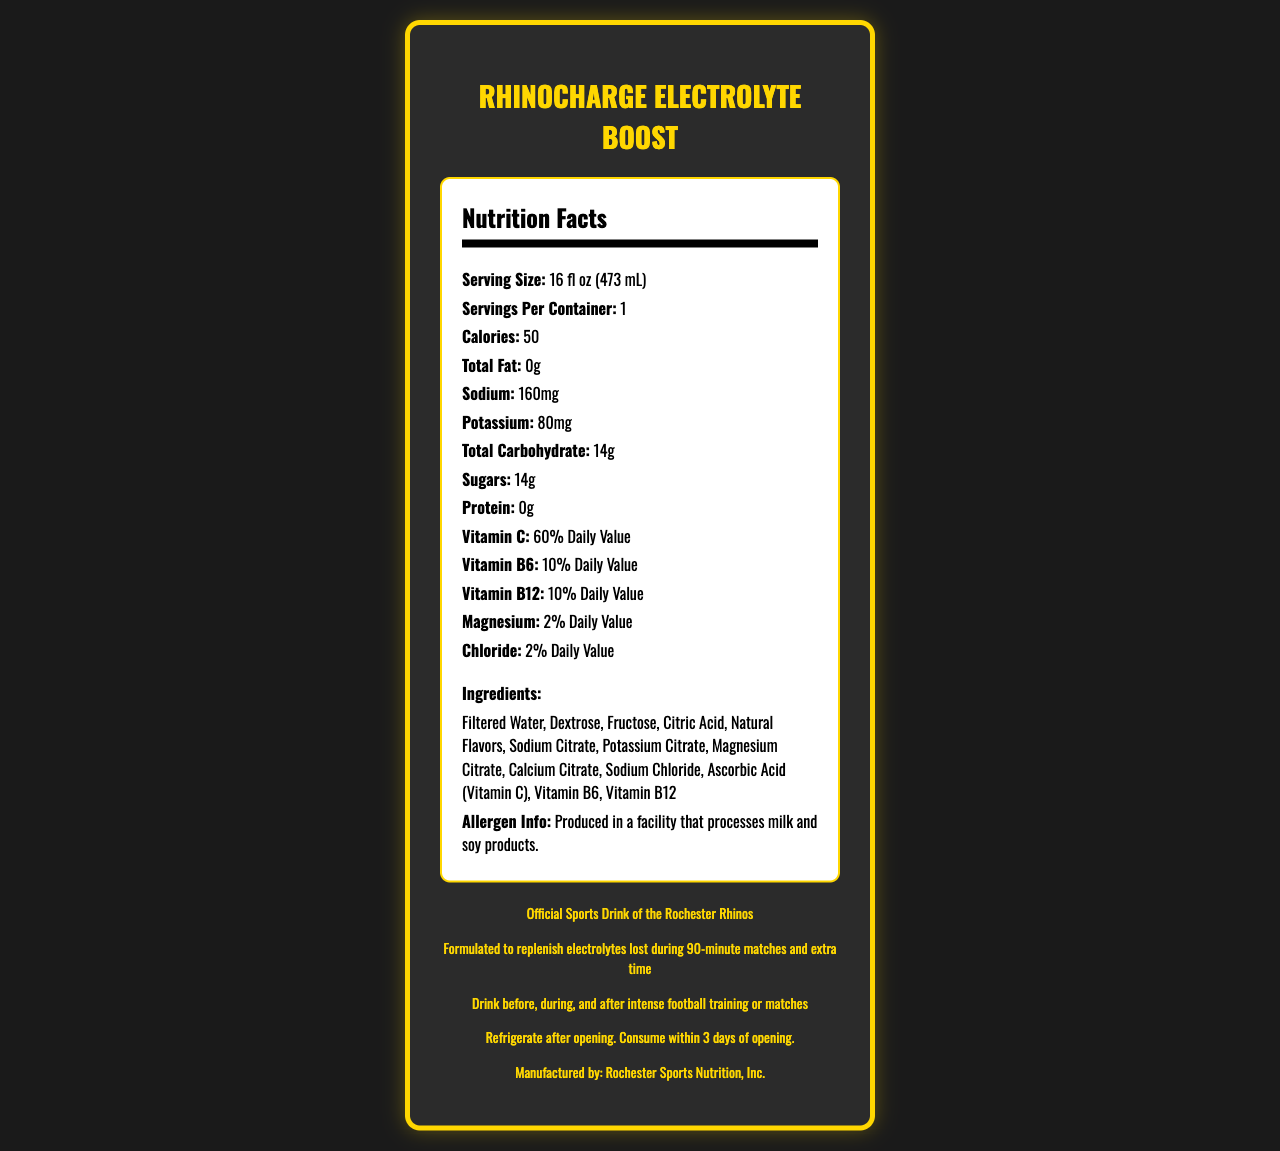what is the serving size of RhinoCharge Electrolyte Boost? The serving size is clearly listed as "16 fl oz (473 mL)" under the Nutrition Facts.
Answer: 16 fl oz (473 mL) how many calories are in a serving? The number of calories is listed as 50 in the Nutrition Facts section.
Answer: 50 what are the main electrolytes in this sports drink? The primary electrolytes mentioned in the ingredients are Sodium, Potassium, and Magnesium Citrate, and Sodium Chloride.
Answer: Sodium, Potassium, Magnesium, Chloride how much sugar is in a serving? The amount of sugar per serving is listed as 14g.
Answer: 14g what percentage of the daily value of Vitamin C does this drink provide? The document states that the drink provides 60% of the daily value for Vitamin C.
Answer: 60% how many servings are in one container of this drink? It is mentioned under the Nutrition Facts that there are 1 serving per container.
Answer: 1 what are the first three ingredients listed? A. Filtered Water, Dextrose, Fructose B. Dextrose, Fructose, Citric Acid C. Fructose, Citric Acid, Natural Flavors The ingredients are listed in order, and the first three are Filtered Water, Dextrose, and Fructose.
Answer: A. Filtered Water, Dextrose, Fructose which nutrient has the highest percentage of daily value? 1. Vitamin C 2. Vitamin B6 3. Magnesium 4. Potassium Among the listed nutrients, Vitamin C has the highest daily value percentage at 60%.
Answer: 1. Vitamin C does the sports drink contain any fat? The Nutrition Facts section indicates that the total fat content is 0g.
Answer: No is the RhinoCharge Electrolyte Boost the official sports drink of the Rochester Rhinos? The document explicitly states that it is endorsed as the "Official Sports Drink of the Rochester Rhinos."
Answer: Yes what is the main use of this sports drink? The document specifies that the drink is formulated to replenish electrolytes lost during 90-minute matches and extra time.
Answer: To replenish electrolytes lost during intense football training or matches what should you do with the drink after opening it? The storage instructions specify to refrigerate after opening and consume within 3 days.
Answer: Refrigerate after opening and consume within 3 days which vitamins are included in the drink? The vitamins listed in the document are Vitamin C, Vitamin B6, and Vitamin B12.
Answer: Vitamin C, Vitamin B6, Vitamin B12 where is this drink produced? The manufacturer information states that it is produced by Rochester Sports Nutrition, Inc.
Answer: Rochester Sports Nutrition, Inc. does this drink contain any allergens? The allergen info states that it is produced in a facility that processes milk and soy products.
Answer: Yes, it's produced in a facility that processes milk and soy products summarize the main idea of the document. The document details the nutrition facts, ingredients, vitamins, and benefits of the RhinoCharge Electrolyte Boost sports drink, emphasizing its use for football players and its endorsement by the Rochester Rhinos.
Answer: The document provides detailed nutrition information for the RhinoCharge Electrolyte Boost sports drink, including serving size, calories, ingredients, vitamins, and electrolytes content. It highlights its formulation to replenish electrolytes during football matches and its endorsement by the Rochester Rhinos. what are the exact amounts of Protein and Total Fat in one serving? Both the amount of Protein and Total Fat are listed as 0g in the Nutrition Facts.
Answer: Protein: 0g, Total Fat: 0g how long does it take for the drink to be effective? The document does not provide any specific information regarding how long it takes for the drink to be effective.
Answer: Not enough information 